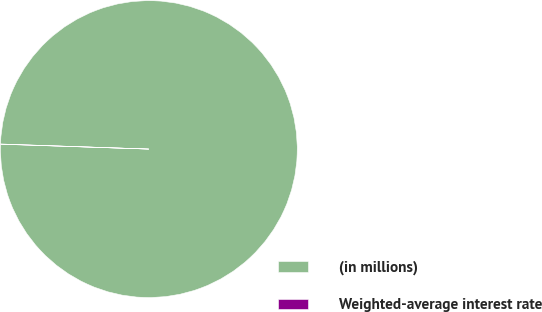<chart> <loc_0><loc_0><loc_500><loc_500><pie_chart><fcel>(in millions)<fcel>Weighted-average interest rate<nl><fcel>99.98%<fcel>0.02%<nl></chart> 